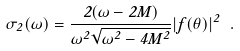Convert formula to latex. <formula><loc_0><loc_0><loc_500><loc_500>\sigma _ { 2 } ( \omega ) = \frac { 2 \Theta ( \omega - 2 M ) } { { \omega ^ { 2 } } \sqrt { { \omega } ^ { 2 } - 4 M ^ { 2 } } } | f ( \theta ) | ^ { 2 } \ .</formula> 